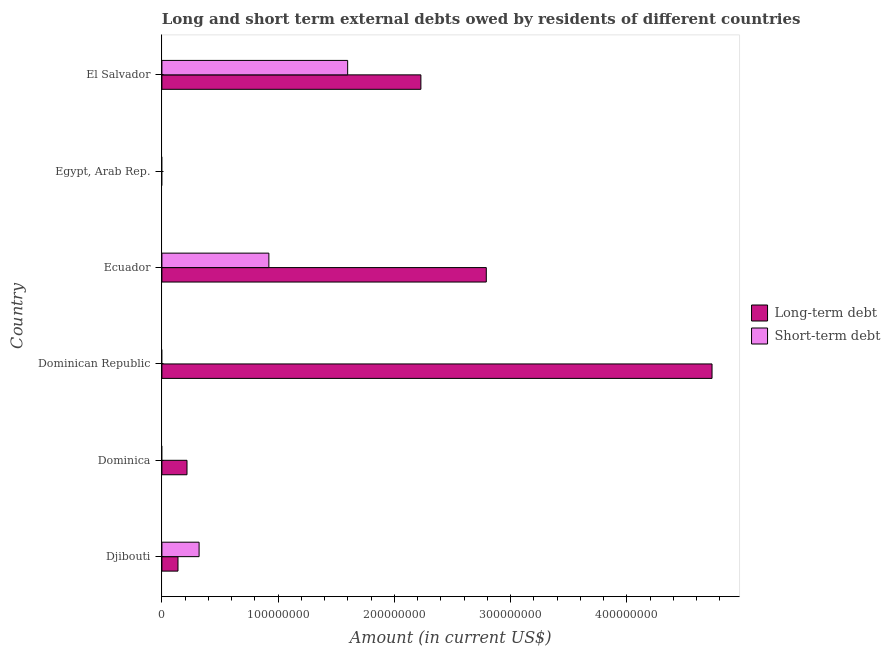How many different coloured bars are there?
Offer a terse response. 2. Are the number of bars per tick equal to the number of legend labels?
Your answer should be very brief. No. How many bars are there on the 1st tick from the top?
Offer a very short reply. 2. What is the label of the 5th group of bars from the top?
Offer a very short reply. Dominica. What is the short-term debts owed by residents in Ecuador?
Give a very brief answer. 9.20e+07. Across all countries, what is the maximum long-term debts owed by residents?
Give a very brief answer. 4.73e+08. Across all countries, what is the minimum long-term debts owed by residents?
Ensure brevity in your answer.  0. In which country was the long-term debts owed by residents maximum?
Your answer should be compact. Dominican Republic. What is the total long-term debts owed by residents in the graph?
Ensure brevity in your answer.  1.01e+09. What is the difference between the long-term debts owed by residents in Ecuador and that in El Salvador?
Provide a short and direct response. 5.63e+07. What is the difference between the short-term debts owed by residents in Ecuador and the long-term debts owed by residents in Djibouti?
Keep it short and to the point. 7.82e+07. What is the average long-term debts owed by residents per country?
Offer a very short reply. 1.68e+08. What is the difference between the short-term debts owed by residents and long-term debts owed by residents in El Salvador?
Provide a short and direct response. -6.30e+07. In how many countries, is the long-term debts owed by residents greater than 440000000 US$?
Your response must be concise. 1. What is the ratio of the long-term debts owed by residents in Djibouti to that in El Salvador?
Keep it short and to the point. 0.06. Is the short-term debts owed by residents in Djibouti less than that in Ecuador?
Ensure brevity in your answer.  Yes. Is the difference between the long-term debts owed by residents in Djibouti and El Salvador greater than the difference between the short-term debts owed by residents in Djibouti and El Salvador?
Keep it short and to the point. No. What is the difference between the highest and the second highest long-term debts owed by residents?
Give a very brief answer. 1.94e+08. What is the difference between the highest and the lowest long-term debts owed by residents?
Your answer should be compact. 4.73e+08. In how many countries, is the short-term debts owed by residents greater than the average short-term debts owed by residents taken over all countries?
Your answer should be very brief. 2. Is the sum of the long-term debts owed by residents in Djibouti and El Salvador greater than the maximum short-term debts owed by residents across all countries?
Provide a succinct answer. Yes. How many bars are there?
Give a very brief answer. 8. Are the values on the major ticks of X-axis written in scientific E-notation?
Your response must be concise. No. Where does the legend appear in the graph?
Ensure brevity in your answer.  Center right. How many legend labels are there?
Make the answer very short. 2. What is the title of the graph?
Your answer should be very brief. Long and short term external debts owed by residents of different countries. Does "Quasi money growth" appear as one of the legend labels in the graph?
Ensure brevity in your answer.  No. What is the label or title of the Y-axis?
Your answer should be compact. Country. What is the Amount (in current US$) of Long-term debt in Djibouti?
Provide a succinct answer. 1.38e+07. What is the Amount (in current US$) in Short-term debt in Djibouti?
Offer a terse response. 3.20e+07. What is the Amount (in current US$) in Long-term debt in Dominica?
Ensure brevity in your answer.  2.16e+07. What is the Amount (in current US$) in Long-term debt in Dominican Republic?
Give a very brief answer. 4.73e+08. What is the Amount (in current US$) in Short-term debt in Dominican Republic?
Your response must be concise. 0. What is the Amount (in current US$) of Long-term debt in Ecuador?
Give a very brief answer. 2.79e+08. What is the Amount (in current US$) in Short-term debt in Ecuador?
Provide a succinct answer. 9.20e+07. What is the Amount (in current US$) in Short-term debt in Egypt, Arab Rep.?
Provide a succinct answer. 0. What is the Amount (in current US$) of Long-term debt in El Salvador?
Offer a very short reply. 2.23e+08. What is the Amount (in current US$) in Short-term debt in El Salvador?
Give a very brief answer. 1.60e+08. Across all countries, what is the maximum Amount (in current US$) of Long-term debt?
Give a very brief answer. 4.73e+08. Across all countries, what is the maximum Amount (in current US$) in Short-term debt?
Offer a terse response. 1.60e+08. What is the total Amount (in current US$) of Long-term debt in the graph?
Provide a succinct answer. 1.01e+09. What is the total Amount (in current US$) in Short-term debt in the graph?
Your answer should be compact. 2.84e+08. What is the difference between the Amount (in current US$) of Long-term debt in Djibouti and that in Dominica?
Give a very brief answer. -7.76e+06. What is the difference between the Amount (in current US$) of Long-term debt in Djibouti and that in Dominican Republic?
Your answer should be very brief. -4.59e+08. What is the difference between the Amount (in current US$) in Long-term debt in Djibouti and that in Ecuador?
Keep it short and to the point. -2.65e+08. What is the difference between the Amount (in current US$) in Short-term debt in Djibouti and that in Ecuador?
Your response must be concise. -6.00e+07. What is the difference between the Amount (in current US$) in Long-term debt in Djibouti and that in El Salvador?
Keep it short and to the point. -2.09e+08. What is the difference between the Amount (in current US$) in Short-term debt in Djibouti and that in El Salvador?
Make the answer very short. -1.28e+08. What is the difference between the Amount (in current US$) in Long-term debt in Dominica and that in Dominican Republic?
Provide a short and direct response. -4.52e+08. What is the difference between the Amount (in current US$) of Long-term debt in Dominica and that in Ecuador?
Provide a succinct answer. -2.57e+08. What is the difference between the Amount (in current US$) of Long-term debt in Dominica and that in El Salvador?
Your answer should be very brief. -2.01e+08. What is the difference between the Amount (in current US$) in Long-term debt in Dominican Republic and that in Ecuador?
Offer a very short reply. 1.94e+08. What is the difference between the Amount (in current US$) in Long-term debt in Dominican Republic and that in El Salvador?
Provide a succinct answer. 2.50e+08. What is the difference between the Amount (in current US$) of Long-term debt in Ecuador and that in El Salvador?
Provide a succinct answer. 5.63e+07. What is the difference between the Amount (in current US$) of Short-term debt in Ecuador and that in El Salvador?
Your answer should be very brief. -6.78e+07. What is the difference between the Amount (in current US$) in Long-term debt in Djibouti and the Amount (in current US$) in Short-term debt in Ecuador?
Your answer should be very brief. -7.82e+07. What is the difference between the Amount (in current US$) of Long-term debt in Djibouti and the Amount (in current US$) of Short-term debt in El Salvador?
Ensure brevity in your answer.  -1.46e+08. What is the difference between the Amount (in current US$) of Long-term debt in Dominica and the Amount (in current US$) of Short-term debt in Ecuador?
Your response must be concise. -7.04e+07. What is the difference between the Amount (in current US$) of Long-term debt in Dominica and the Amount (in current US$) of Short-term debt in El Salvador?
Keep it short and to the point. -1.38e+08. What is the difference between the Amount (in current US$) of Long-term debt in Dominican Republic and the Amount (in current US$) of Short-term debt in Ecuador?
Offer a terse response. 3.81e+08. What is the difference between the Amount (in current US$) of Long-term debt in Dominican Republic and the Amount (in current US$) of Short-term debt in El Salvador?
Make the answer very short. 3.13e+08. What is the difference between the Amount (in current US$) of Long-term debt in Ecuador and the Amount (in current US$) of Short-term debt in El Salvador?
Offer a terse response. 1.19e+08. What is the average Amount (in current US$) in Long-term debt per country?
Make the answer very short. 1.68e+08. What is the average Amount (in current US$) in Short-term debt per country?
Provide a succinct answer. 4.73e+07. What is the difference between the Amount (in current US$) of Long-term debt and Amount (in current US$) of Short-term debt in Djibouti?
Provide a short and direct response. -1.82e+07. What is the difference between the Amount (in current US$) of Long-term debt and Amount (in current US$) of Short-term debt in Ecuador?
Keep it short and to the point. 1.87e+08. What is the difference between the Amount (in current US$) in Long-term debt and Amount (in current US$) in Short-term debt in El Salvador?
Ensure brevity in your answer.  6.30e+07. What is the ratio of the Amount (in current US$) of Long-term debt in Djibouti to that in Dominica?
Your answer should be very brief. 0.64. What is the ratio of the Amount (in current US$) in Long-term debt in Djibouti to that in Dominican Republic?
Your response must be concise. 0.03. What is the ratio of the Amount (in current US$) in Long-term debt in Djibouti to that in Ecuador?
Give a very brief answer. 0.05. What is the ratio of the Amount (in current US$) of Short-term debt in Djibouti to that in Ecuador?
Ensure brevity in your answer.  0.35. What is the ratio of the Amount (in current US$) of Long-term debt in Djibouti to that in El Salvador?
Make the answer very short. 0.06. What is the ratio of the Amount (in current US$) of Short-term debt in Djibouti to that in El Salvador?
Offer a terse response. 0.2. What is the ratio of the Amount (in current US$) of Long-term debt in Dominica to that in Dominican Republic?
Keep it short and to the point. 0.05. What is the ratio of the Amount (in current US$) of Long-term debt in Dominica to that in Ecuador?
Ensure brevity in your answer.  0.08. What is the ratio of the Amount (in current US$) in Long-term debt in Dominica to that in El Salvador?
Offer a terse response. 0.1. What is the ratio of the Amount (in current US$) of Long-term debt in Dominican Republic to that in Ecuador?
Make the answer very short. 1.7. What is the ratio of the Amount (in current US$) of Long-term debt in Dominican Republic to that in El Salvador?
Make the answer very short. 2.12. What is the ratio of the Amount (in current US$) of Long-term debt in Ecuador to that in El Salvador?
Provide a succinct answer. 1.25. What is the ratio of the Amount (in current US$) of Short-term debt in Ecuador to that in El Salvador?
Provide a short and direct response. 0.58. What is the difference between the highest and the second highest Amount (in current US$) in Long-term debt?
Give a very brief answer. 1.94e+08. What is the difference between the highest and the second highest Amount (in current US$) of Short-term debt?
Make the answer very short. 6.78e+07. What is the difference between the highest and the lowest Amount (in current US$) in Long-term debt?
Your response must be concise. 4.73e+08. What is the difference between the highest and the lowest Amount (in current US$) of Short-term debt?
Your response must be concise. 1.60e+08. 